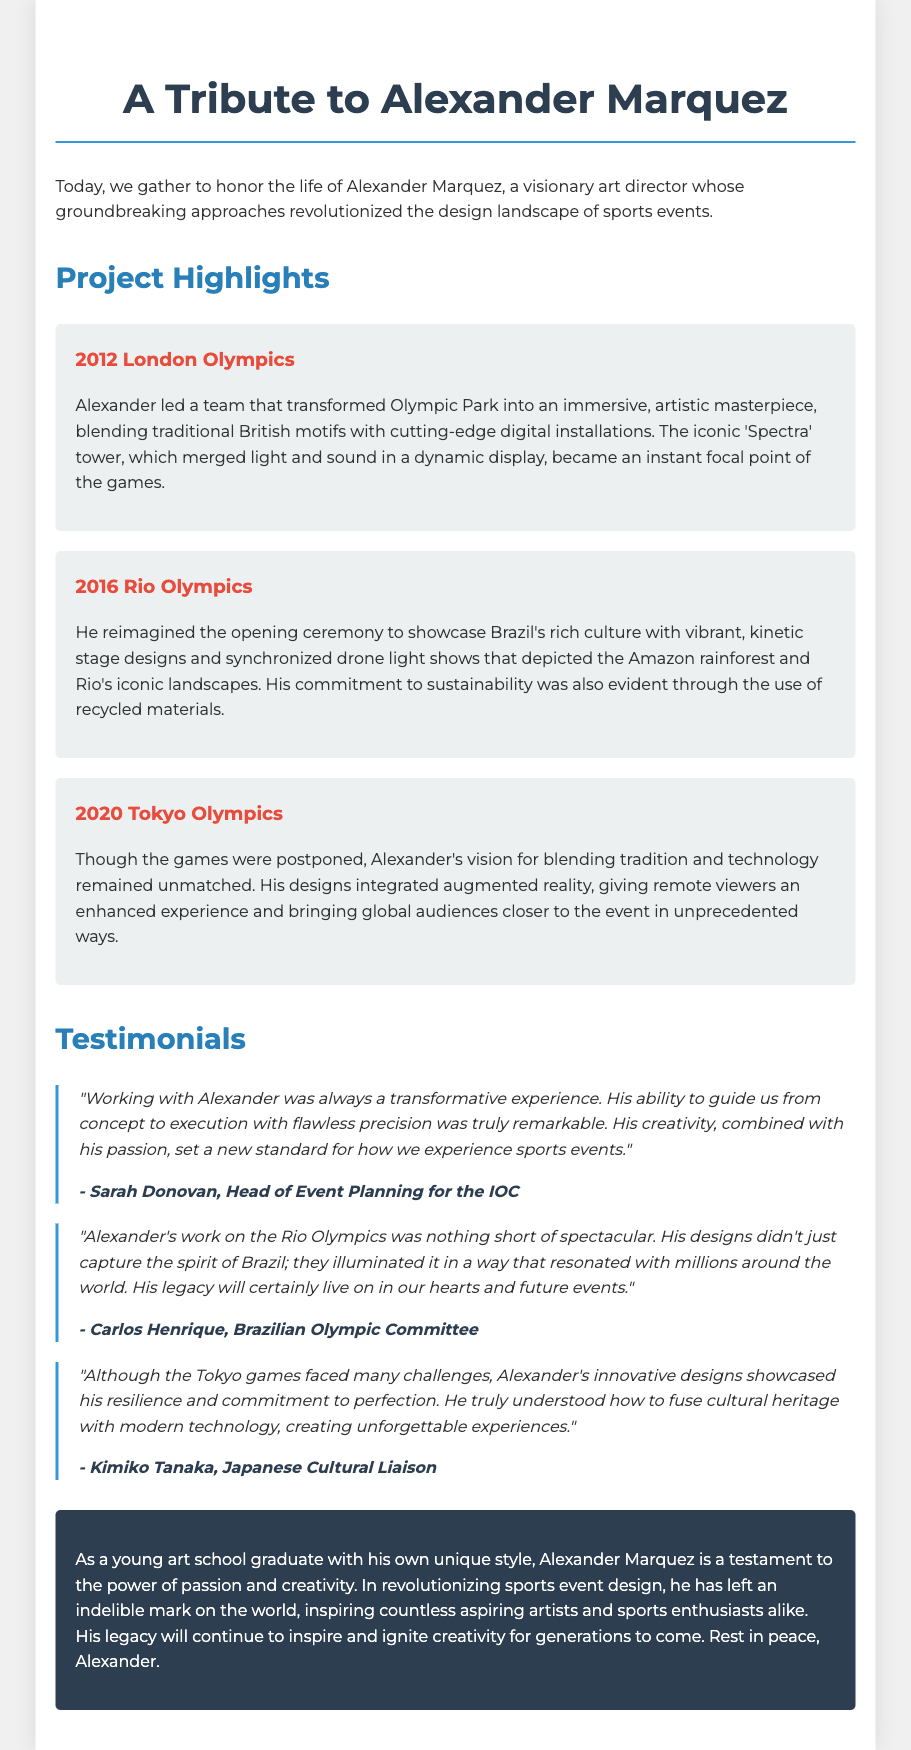What was Alexander Marquez's role? Alexander Marquez was a visionary art director, responsible for revolutionizing sports event design.
Answer: art director When did Alexander lead the team for the London Olympics? The document states that this event took place in 2012.
Answer: 2012 What unique feature did the 'Spectra' tower include? The 'Spectra' tower was known for merging light and sound in a dynamic display.
Answer: light and sound Which Olympic event did Alexander reimagine with drone light shows? The document mentions the Rio Olympics as the event he reimagined with vibrant, kinetic stage designs and synchronized drone light shows.
Answer: Rio Olympics Who praised Alexander's work for its transformative experience? Sarah Donovan, Head of Event Planning for the IOC, made this statement.
Answer: Sarah Donovan What was emphasized in Alexander's designs for the Tokyo Olympics? The designs integrated augmented reality to enhance the viewing experience for remote viewers.
Answer: augmented reality Which materials did Alexander utilize to promote sustainability during his projects? He used recycled materials in his designs, particularly evident during the Rio Olympics.
Answer: recycled materials What challenge did the Tokyo games face? The document specifies that the Tokyo games were postponed, which is mentioned as a challenge.
Answer: postponed How did Alexander's work impact aspiring artists? His revolution in sports event design continues to inspire countless aspiring artists and sports enthusiasts alike.
Answer: inspire countless aspiring artists 